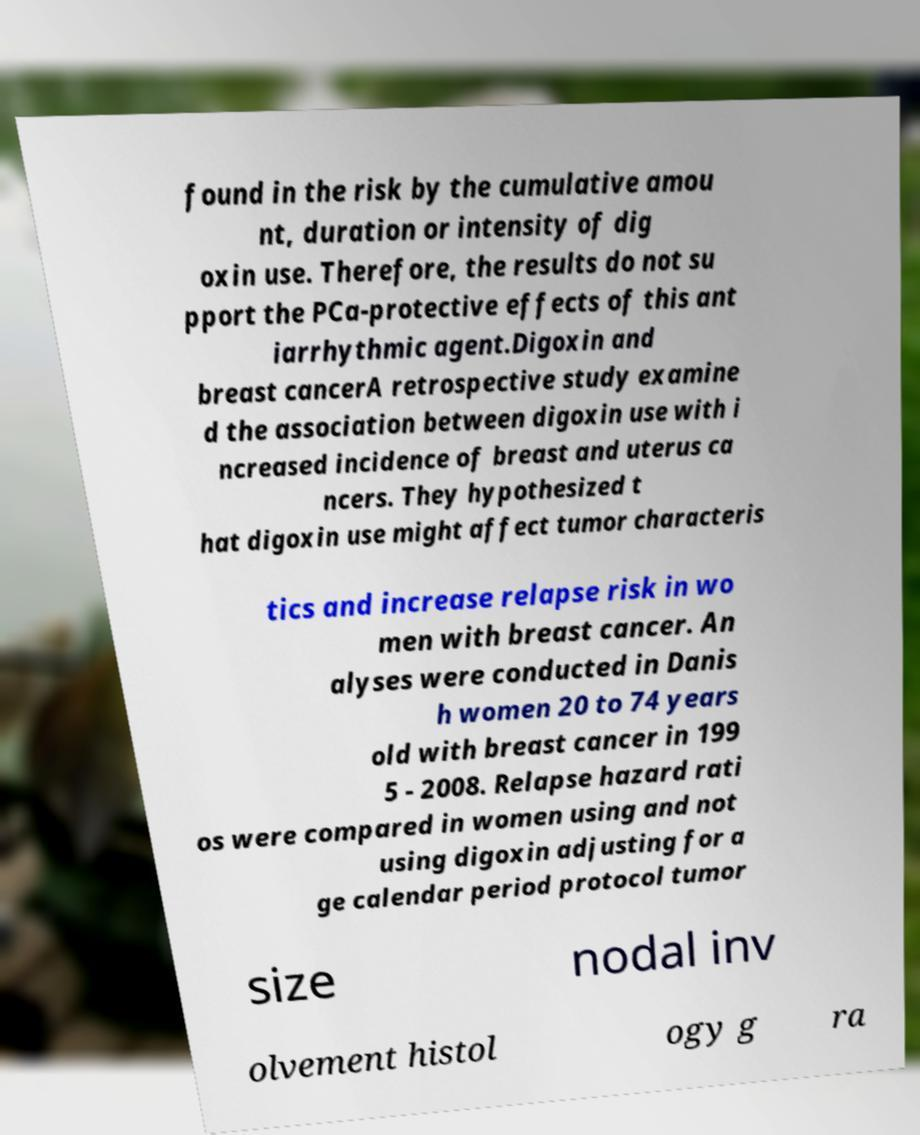Could you assist in decoding the text presented in this image and type it out clearly? found in the risk by the cumulative amou nt, duration or intensity of dig oxin use. Therefore, the results do not su pport the PCa-protective effects of this ant iarrhythmic agent.Digoxin and breast cancerA retrospective study examine d the association between digoxin use with i ncreased incidence of breast and uterus ca ncers. They hypothesized t hat digoxin use might affect tumor characteris tics and increase relapse risk in wo men with breast cancer. An alyses were conducted in Danis h women 20 to 74 years old with breast cancer in 199 5 - 2008. Relapse hazard rati os were compared in women using and not using digoxin adjusting for a ge calendar period protocol tumor size nodal inv olvement histol ogy g ra 